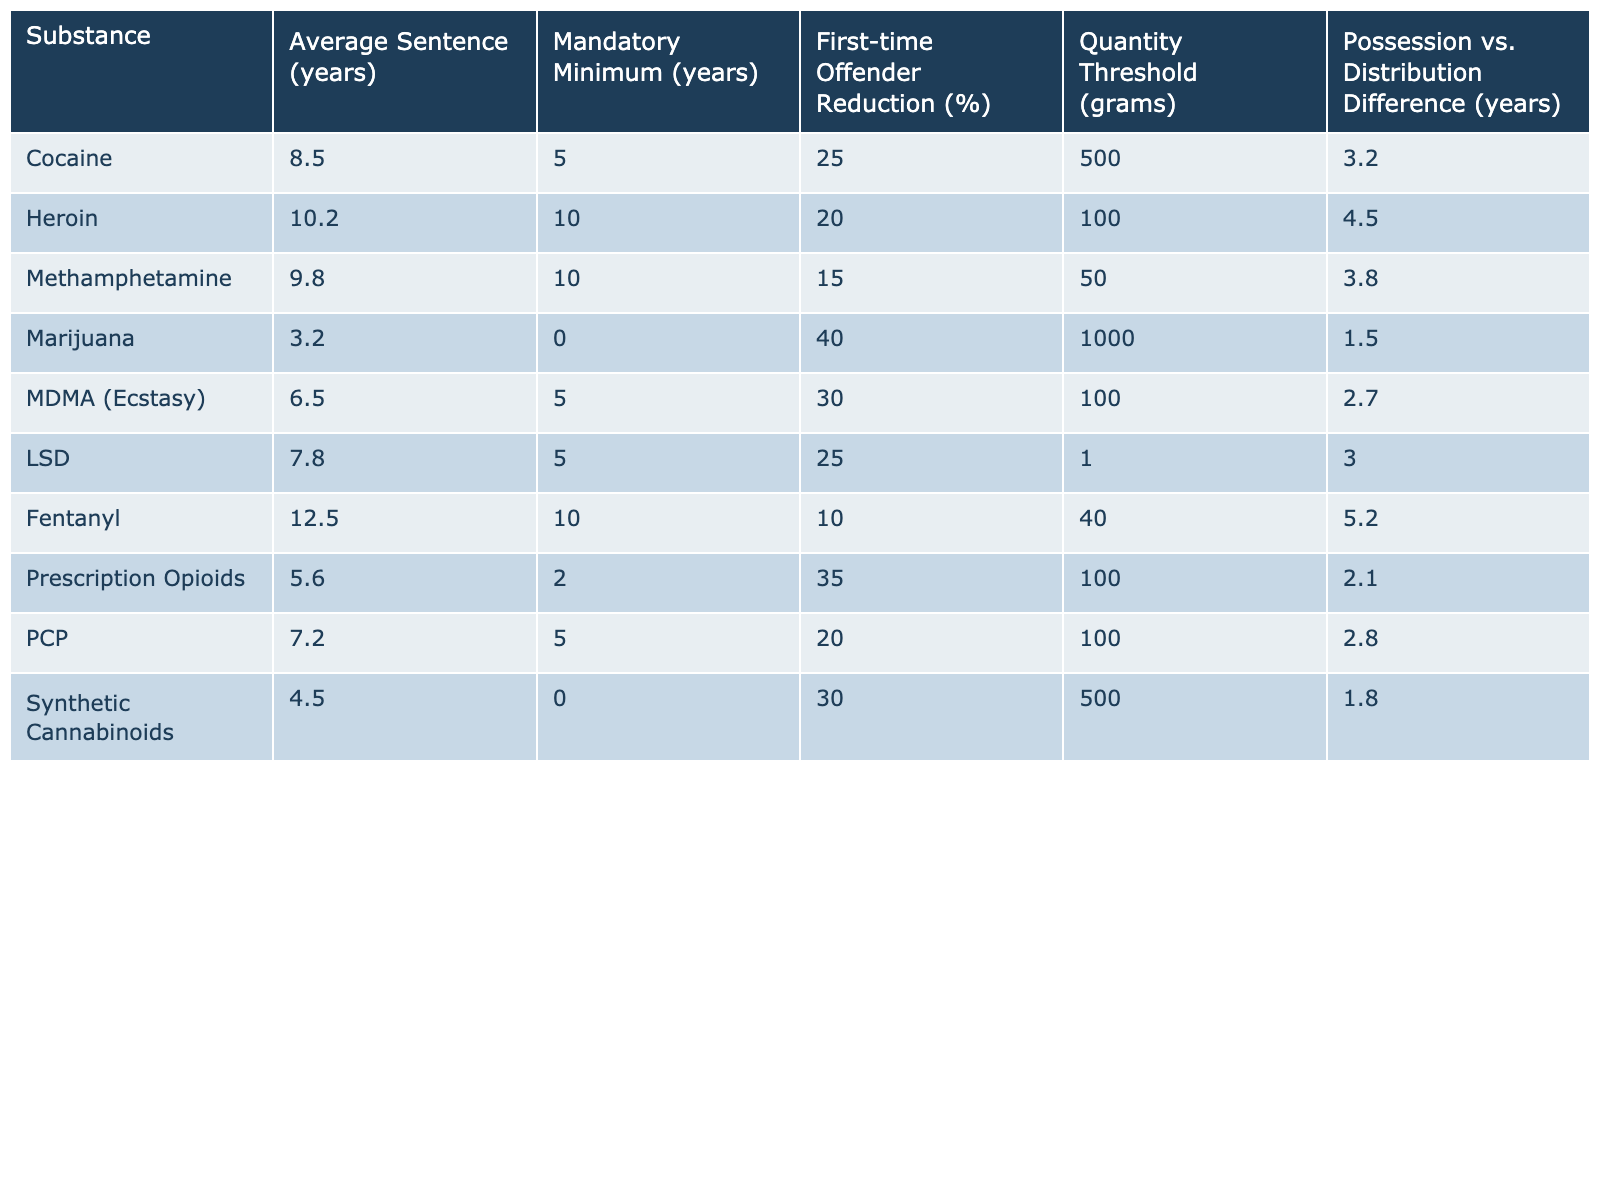What is the average sentence for possession of cocaine? According to the table, the average sentence for cocaine is listed under the "Average Sentence (years)" column, which shows a value of 8.5 years.
Answer: 8.5 years What is the mandatory minimum sentence for heroin? The table specifies that the mandatory minimum sentence for heroin is 10 years, as indicated in the "Mandatory Minimum (years)" column.
Answer: 10 years How much longer is the average sentence for fentanyl compared to marijuana? The average sentence for fentanyl is 12.5 years and for marijuana is 3.2 years. The difference is calculated as 12.5 - 3.2 = 9.3 years.
Answer: 9.3 years Which substance has the highest average sentence? By looking at the "Average Sentence (years)" column, fentanyl has the highest average sentence of 12.5 years.
Answer: Fentanyl Does MDMA have a lower average sentence than cocaine? The average sentence for MDMA is 6.5 years, while for cocaine it is 8.5 years. Since 6.5 is less than 8.5, the statement is true.
Answer: Yes What is the average sentence for first-time offenders for methamphetamine? The table shows that the average sentence for methamphetamine is 9.8 years. The table does not explicitly state a different sentence for first-time offenders, so it is assumed to be the same.
Answer: 9.8 years What is the average sentence difference between PCP and synthetic cannabinoids? PCP has an average sentence of 7.2 years and synthetic cannabinoids have 4.5 years. The difference can be calculated as 7.2 - 4.5 = 2.7 years.
Answer: 2.7 years Which substance has the lowest quantity threshold for possession? The table indicates that LSD has the lowest quantity threshold for possession at 1 gram, which can be found in the "Quantity Threshold (grams)" column.
Answer: LSD Is the first-time offender reduction percentage higher for marijuana than for fentanyl? The first-time offender reduction percentage for marijuana is 40% and for fentanyl is 10%. Since 40% is greater than 10%, the statement is true.
Answer: Yes If you average the mandatory minimum sentences of cocaine, heroin, and methamphetamine, what is the result? The mandatory minimum sentences are 5 years for cocaine, 10 years for heroin, and 10 years for methamphetamine. The average is calculated as (5 + 10 + 10) / 3 = 8.33 years.
Answer: 8.33 years 